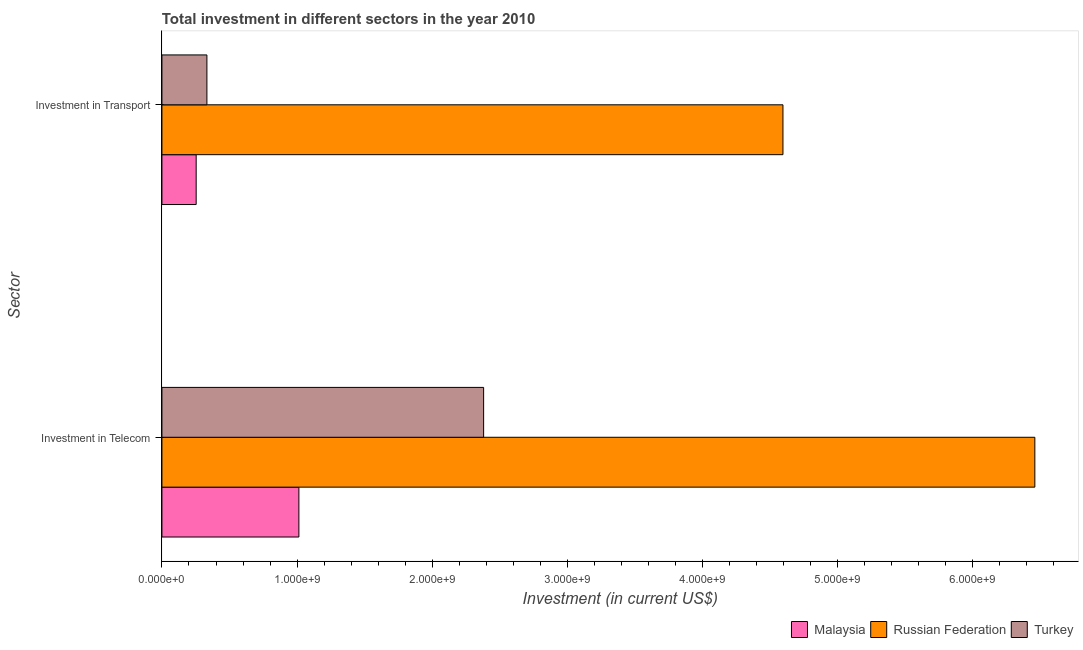Are the number of bars per tick equal to the number of legend labels?
Your response must be concise. Yes. How many bars are there on the 2nd tick from the bottom?
Offer a terse response. 3. What is the label of the 2nd group of bars from the top?
Provide a succinct answer. Investment in Telecom. What is the investment in telecom in Turkey?
Offer a terse response. 2.38e+09. Across all countries, what is the maximum investment in telecom?
Your answer should be very brief. 6.46e+09. Across all countries, what is the minimum investment in telecom?
Make the answer very short. 1.01e+09. In which country was the investment in transport maximum?
Provide a succinct answer. Russian Federation. In which country was the investment in telecom minimum?
Keep it short and to the point. Malaysia. What is the total investment in telecom in the graph?
Provide a succinct answer. 9.85e+09. What is the difference between the investment in telecom in Russian Federation and that in Malaysia?
Offer a very short reply. 5.45e+09. What is the difference between the investment in transport in Turkey and the investment in telecom in Russian Federation?
Ensure brevity in your answer.  -6.13e+09. What is the average investment in transport per country?
Provide a succinct answer. 1.73e+09. What is the difference between the investment in telecom and investment in transport in Turkey?
Your answer should be compact. 2.05e+09. What is the ratio of the investment in transport in Russian Federation to that in Malaysia?
Your response must be concise. 18.14. Is the investment in transport in Turkey less than that in Malaysia?
Offer a terse response. No. What does the 1st bar from the top in Investment in Transport represents?
Keep it short and to the point. Turkey. How many countries are there in the graph?
Provide a succinct answer. 3. Where does the legend appear in the graph?
Keep it short and to the point. Bottom right. How are the legend labels stacked?
Make the answer very short. Horizontal. What is the title of the graph?
Your response must be concise. Total investment in different sectors in the year 2010. Does "Togo" appear as one of the legend labels in the graph?
Provide a succinct answer. No. What is the label or title of the X-axis?
Offer a very short reply. Investment (in current US$). What is the label or title of the Y-axis?
Your answer should be compact. Sector. What is the Investment (in current US$) of Malaysia in Investment in Telecom?
Your response must be concise. 1.01e+09. What is the Investment (in current US$) in Russian Federation in Investment in Telecom?
Offer a terse response. 6.46e+09. What is the Investment (in current US$) of Turkey in Investment in Telecom?
Offer a terse response. 2.38e+09. What is the Investment (in current US$) of Malaysia in Investment in Transport?
Offer a terse response. 2.53e+08. What is the Investment (in current US$) in Russian Federation in Investment in Transport?
Ensure brevity in your answer.  4.60e+09. What is the Investment (in current US$) of Turkey in Investment in Transport?
Offer a very short reply. 3.33e+08. Across all Sector, what is the maximum Investment (in current US$) in Malaysia?
Your answer should be very brief. 1.01e+09. Across all Sector, what is the maximum Investment (in current US$) of Russian Federation?
Ensure brevity in your answer.  6.46e+09. Across all Sector, what is the maximum Investment (in current US$) of Turkey?
Your answer should be very brief. 2.38e+09. Across all Sector, what is the minimum Investment (in current US$) of Malaysia?
Make the answer very short. 2.53e+08. Across all Sector, what is the minimum Investment (in current US$) of Russian Federation?
Ensure brevity in your answer.  4.60e+09. Across all Sector, what is the minimum Investment (in current US$) of Turkey?
Ensure brevity in your answer.  3.33e+08. What is the total Investment (in current US$) of Malaysia in the graph?
Your response must be concise. 1.27e+09. What is the total Investment (in current US$) in Russian Federation in the graph?
Offer a terse response. 1.11e+1. What is the total Investment (in current US$) of Turkey in the graph?
Provide a succinct answer. 2.71e+09. What is the difference between the Investment (in current US$) of Malaysia in Investment in Telecom and that in Investment in Transport?
Offer a very short reply. 7.60e+08. What is the difference between the Investment (in current US$) of Russian Federation in Investment in Telecom and that in Investment in Transport?
Provide a short and direct response. 1.86e+09. What is the difference between the Investment (in current US$) in Turkey in Investment in Telecom and that in Investment in Transport?
Offer a terse response. 2.05e+09. What is the difference between the Investment (in current US$) in Malaysia in Investment in Telecom and the Investment (in current US$) in Russian Federation in Investment in Transport?
Your response must be concise. -3.58e+09. What is the difference between the Investment (in current US$) in Malaysia in Investment in Telecom and the Investment (in current US$) in Turkey in Investment in Transport?
Your response must be concise. 6.81e+08. What is the difference between the Investment (in current US$) of Russian Federation in Investment in Telecom and the Investment (in current US$) of Turkey in Investment in Transport?
Offer a terse response. 6.13e+09. What is the average Investment (in current US$) of Malaysia per Sector?
Provide a succinct answer. 6.33e+08. What is the average Investment (in current US$) of Russian Federation per Sector?
Your answer should be compact. 5.53e+09. What is the average Investment (in current US$) of Turkey per Sector?
Offer a terse response. 1.36e+09. What is the difference between the Investment (in current US$) in Malaysia and Investment (in current US$) in Russian Federation in Investment in Telecom?
Give a very brief answer. -5.45e+09. What is the difference between the Investment (in current US$) in Malaysia and Investment (in current US$) in Turkey in Investment in Telecom?
Your response must be concise. -1.37e+09. What is the difference between the Investment (in current US$) of Russian Federation and Investment (in current US$) of Turkey in Investment in Telecom?
Your answer should be very brief. 4.08e+09. What is the difference between the Investment (in current US$) of Malaysia and Investment (in current US$) of Russian Federation in Investment in Transport?
Offer a terse response. -4.34e+09. What is the difference between the Investment (in current US$) of Malaysia and Investment (in current US$) of Turkey in Investment in Transport?
Provide a short and direct response. -7.94e+07. What is the difference between the Investment (in current US$) in Russian Federation and Investment (in current US$) in Turkey in Investment in Transport?
Your answer should be compact. 4.26e+09. What is the ratio of the Investment (in current US$) of Malaysia in Investment in Telecom to that in Investment in Transport?
Offer a terse response. 4. What is the ratio of the Investment (in current US$) of Russian Federation in Investment in Telecom to that in Investment in Transport?
Your response must be concise. 1.41. What is the ratio of the Investment (in current US$) of Turkey in Investment in Telecom to that in Investment in Transport?
Offer a terse response. 7.16. What is the difference between the highest and the second highest Investment (in current US$) of Malaysia?
Provide a short and direct response. 7.60e+08. What is the difference between the highest and the second highest Investment (in current US$) in Russian Federation?
Ensure brevity in your answer.  1.86e+09. What is the difference between the highest and the second highest Investment (in current US$) in Turkey?
Your answer should be compact. 2.05e+09. What is the difference between the highest and the lowest Investment (in current US$) in Malaysia?
Your response must be concise. 7.60e+08. What is the difference between the highest and the lowest Investment (in current US$) in Russian Federation?
Offer a very short reply. 1.86e+09. What is the difference between the highest and the lowest Investment (in current US$) of Turkey?
Make the answer very short. 2.05e+09. 